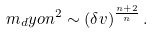Convert formula to latex. <formula><loc_0><loc_0><loc_500><loc_500>m _ { d } y o n ^ { 2 } \sim ( \delta v ) ^ { \frac { n + 2 } { n } } \, .</formula> 